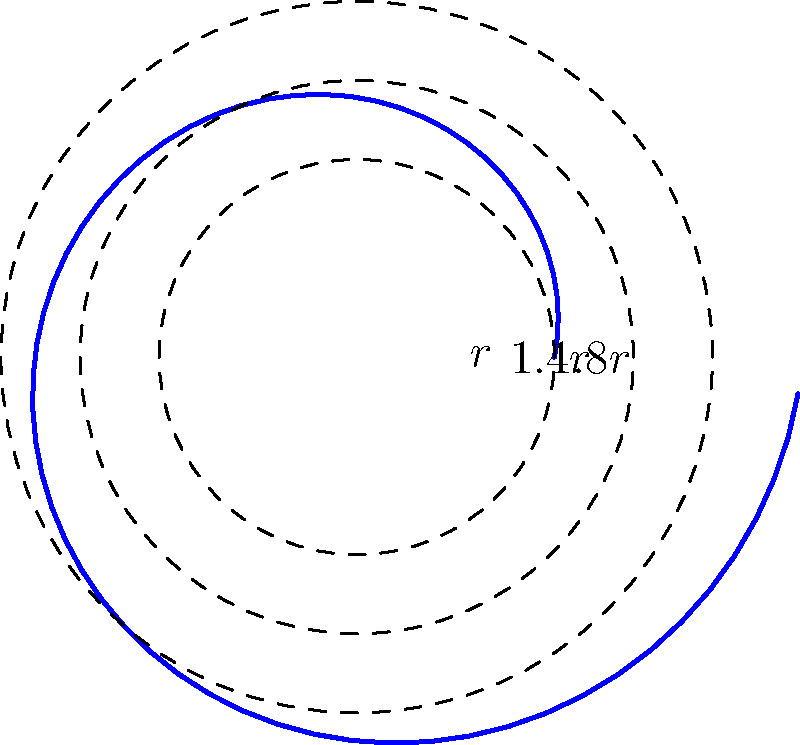As an amateur naturalist studying snail shells, you've encountered a fascinating spiral-shaped shell. To estimate its surface area, you decide to model it using circular segments. The shell starts with a radius of $r$ and expands outward in three segments with radii $r$, $1.4r$, and $1.8r$ respectively. If $r = 2$ cm, what is the total area of these three circular segments that approximate the snail's shell surface? Let's approach this step-by-step:

1) The area of a circle is given by the formula $A = \pi r^2$.

2) For the first segment:
   $A_1 = \pi r^2 = \pi (2\text{ cm})^2 = 4\pi \text{ cm}^2$

3) For the second segment:
   $A_2 = \pi (1.4r)^2 = \pi (1.4 \cdot 2\text{ cm})^2 = 7.84\pi \text{ cm}^2$

4) For the third segment:
   $A_3 = \pi (1.8r)^2 = \pi (1.8 \cdot 2\text{ cm})^2 = 12.96\pi \text{ cm}^2$

5) The total area is the sum of these three segments:
   $A_{total} = A_1 + A_2 + A_3$
   $A_{total} = 4\pi + 7.84\pi + 12.96\pi = 24.8\pi \text{ cm}^2$

6) Calculating the final value:
   $A_{total} = 24.8\pi \approx 77.91 \text{ cm}^2$

Therefore, the total area of the three circular segments approximating the snail's shell surface is approximately 77.91 square centimeters.
Answer: $77.91 \text{ cm}^2$ 